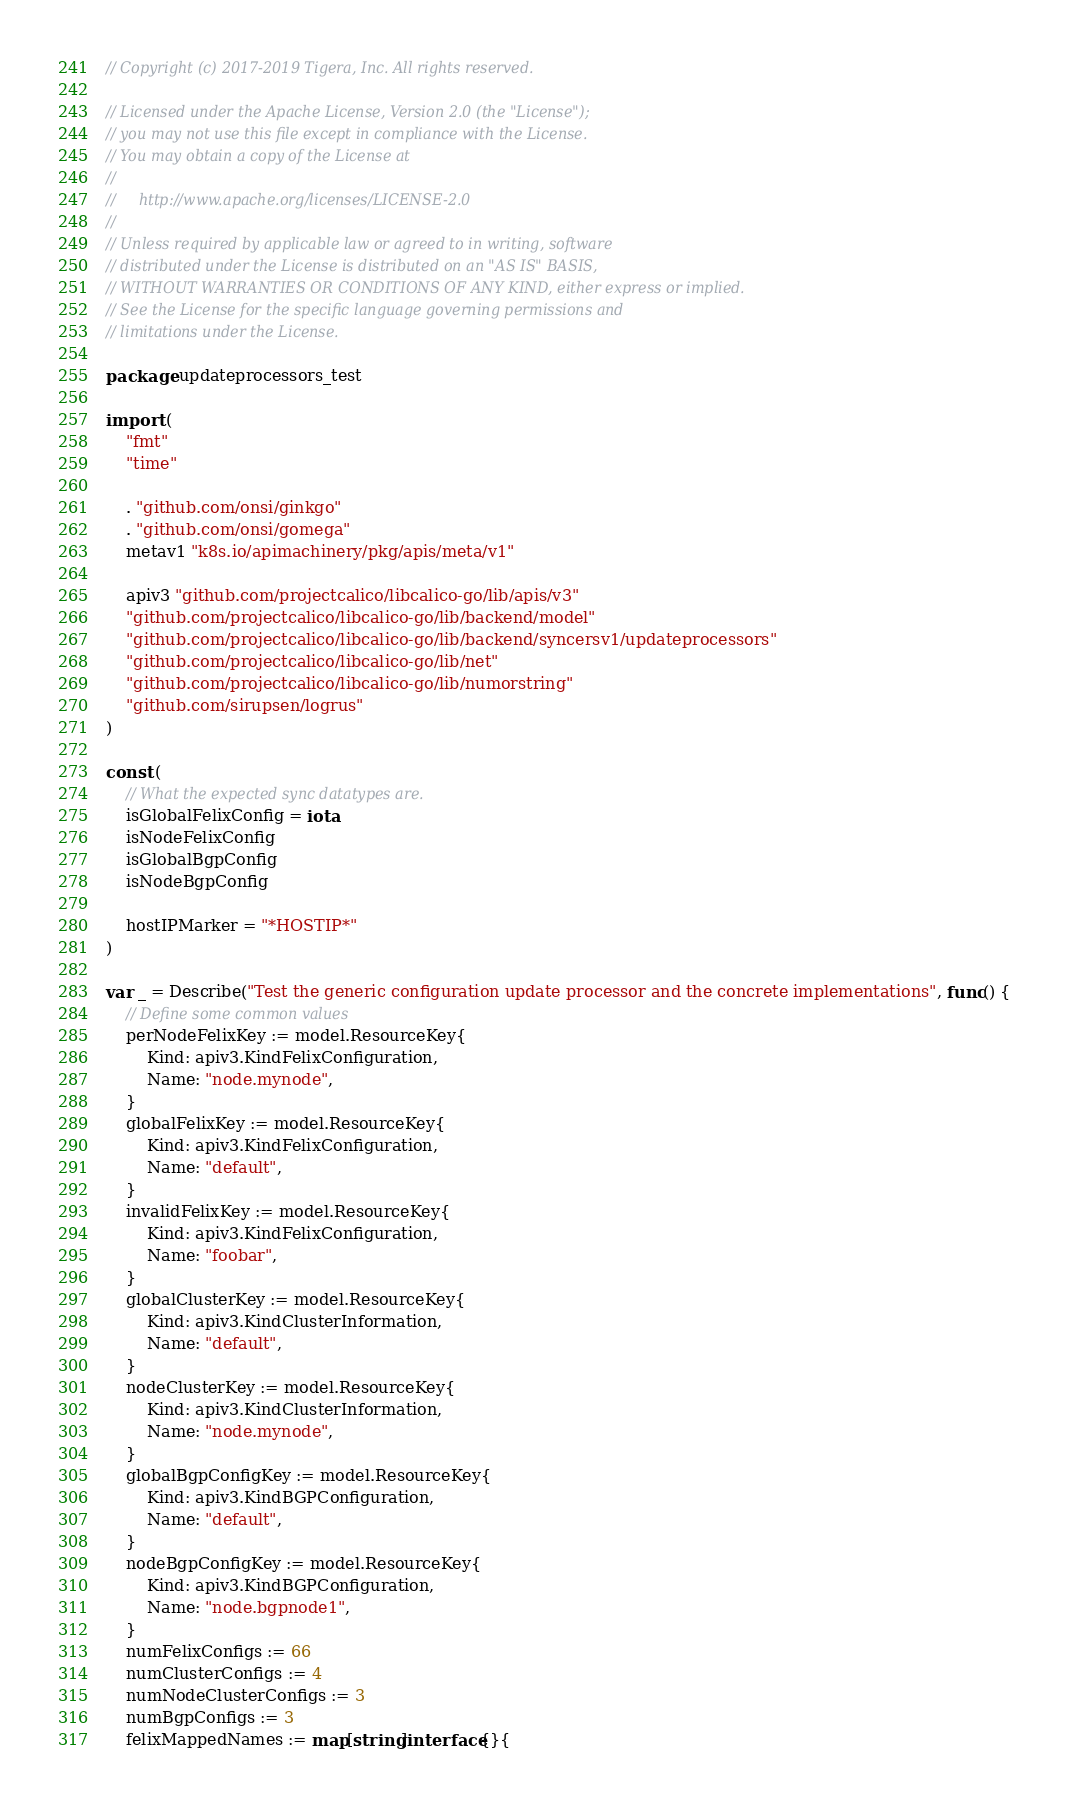<code> <loc_0><loc_0><loc_500><loc_500><_Go_>// Copyright (c) 2017-2019 Tigera, Inc. All rights reserved.

// Licensed under the Apache License, Version 2.0 (the "License");
// you may not use this file except in compliance with the License.
// You may obtain a copy of the License at
//
//     http://www.apache.org/licenses/LICENSE-2.0
//
// Unless required by applicable law or agreed to in writing, software
// distributed under the License is distributed on an "AS IS" BASIS,
// WITHOUT WARRANTIES OR CONDITIONS OF ANY KIND, either express or implied.
// See the License for the specific language governing permissions and
// limitations under the License.

package updateprocessors_test

import (
	"fmt"
	"time"

	. "github.com/onsi/ginkgo"
	. "github.com/onsi/gomega"
	metav1 "k8s.io/apimachinery/pkg/apis/meta/v1"

	apiv3 "github.com/projectcalico/libcalico-go/lib/apis/v3"
	"github.com/projectcalico/libcalico-go/lib/backend/model"
	"github.com/projectcalico/libcalico-go/lib/backend/syncersv1/updateprocessors"
	"github.com/projectcalico/libcalico-go/lib/net"
	"github.com/projectcalico/libcalico-go/lib/numorstring"
	"github.com/sirupsen/logrus"
)

const (
	// What the expected sync datatypes are.
	isGlobalFelixConfig = iota
	isNodeFelixConfig
	isGlobalBgpConfig
	isNodeBgpConfig

	hostIPMarker = "*HOSTIP*"
)

var _ = Describe("Test the generic configuration update processor and the concrete implementations", func() {
	// Define some common values
	perNodeFelixKey := model.ResourceKey{
		Kind: apiv3.KindFelixConfiguration,
		Name: "node.mynode",
	}
	globalFelixKey := model.ResourceKey{
		Kind: apiv3.KindFelixConfiguration,
		Name: "default",
	}
	invalidFelixKey := model.ResourceKey{
		Kind: apiv3.KindFelixConfiguration,
		Name: "foobar",
	}
	globalClusterKey := model.ResourceKey{
		Kind: apiv3.KindClusterInformation,
		Name: "default",
	}
	nodeClusterKey := model.ResourceKey{
		Kind: apiv3.KindClusterInformation,
		Name: "node.mynode",
	}
	globalBgpConfigKey := model.ResourceKey{
		Kind: apiv3.KindBGPConfiguration,
		Name: "default",
	}
	nodeBgpConfigKey := model.ResourceKey{
		Kind: apiv3.KindBGPConfiguration,
		Name: "node.bgpnode1",
	}
	numFelixConfigs := 66
	numClusterConfigs := 4
	numNodeClusterConfigs := 3
	numBgpConfigs := 3
	felixMappedNames := map[string]interface{}{</code> 